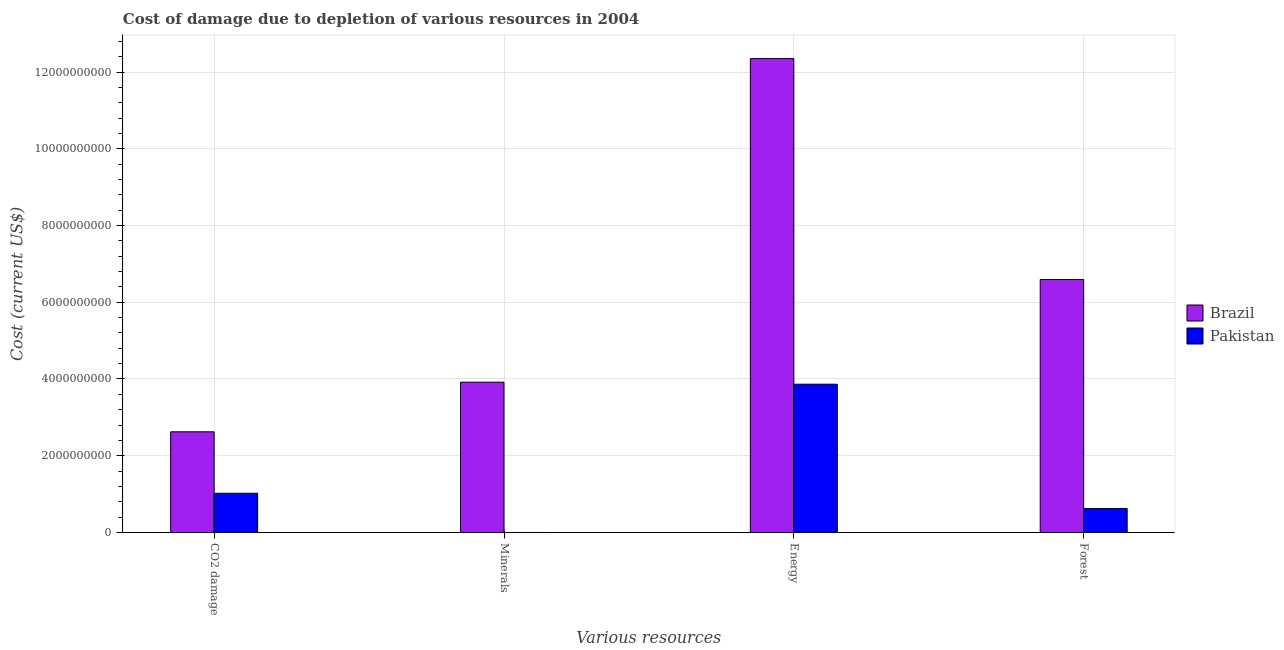How many different coloured bars are there?
Ensure brevity in your answer.  2. Are the number of bars per tick equal to the number of legend labels?
Ensure brevity in your answer.  Yes. Are the number of bars on each tick of the X-axis equal?
Offer a terse response. Yes. How many bars are there on the 1st tick from the left?
Provide a short and direct response. 2. How many bars are there on the 1st tick from the right?
Your answer should be very brief. 2. What is the label of the 2nd group of bars from the left?
Keep it short and to the point. Minerals. What is the cost of damage due to depletion of energy in Brazil?
Your answer should be very brief. 1.24e+1. Across all countries, what is the maximum cost of damage due to depletion of coal?
Your response must be concise. 2.62e+09. Across all countries, what is the minimum cost of damage due to depletion of coal?
Your answer should be compact. 1.02e+09. In which country was the cost of damage due to depletion of coal minimum?
Your answer should be compact. Pakistan. What is the total cost of damage due to depletion of forests in the graph?
Your answer should be very brief. 7.22e+09. What is the difference between the cost of damage due to depletion of coal in Pakistan and that in Brazil?
Provide a short and direct response. -1.60e+09. What is the difference between the cost of damage due to depletion of forests in Pakistan and the cost of damage due to depletion of energy in Brazil?
Make the answer very short. -1.17e+1. What is the average cost of damage due to depletion of coal per country?
Offer a very short reply. 1.82e+09. What is the difference between the cost of damage due to depletion of forests and cost of damage due to depletion of coal in Pakistan?
Offer a very short reply. -3.98e+08. What is the ratio of the cost of damage due to depletion of energy in Pakistan to that in Brazil?
Give a very brief answer. 0.31. Is the cost of damage due to depletion of coal in Pakistan less than that in Brazil?
Keep it short and to the point. Yes. Is the difference between the cost of damage due to depletion of energy in Pakistan and Brazil greater than the difference between the cost of damage due to depletion of coal in Pakistan and Brazil?
Your answer should be compact. No. What is the difference between the highest and the second highest cost of damage due to depletion of energy?
Make the answer very short. 8.49e+09. What is the difference between the highest and the lowest cost of damage due to depletion of forests?
Provide a succinct answer. 5.97e+09. Is the sum of the cost of damage due to depletion of energy in Brazil and Pakistan greater than the maximum cost of damage due to depletion of coal across all countries?
Give a very brief answer. Yes. What does the 2nd bar from the right in Minerals represents?
Your answer should be compact. Brazil. How many bars are there?
Make the answer very short. 8. Are all the bars in the graph horizontal?
Your answer should be very brief. No. How many countries are there in the graph?
Provide a short and direct response. 2. Does the graph contain any zero values?
Give a very brief answer. No. Does the graph contain grids?
Your answer should be very brief. Yes. What is the title of the graph?
Your answer should be compact. Cost of damage due to depletion of various resources in 2004 . What is the label or title of the X-axis?
Give a very brief answer. Various resources. What is the label or title of the Y-axis?
Provide a short and direct response. Cost (current US$). What is the Cost (current US$) of Brazil in CO2 damage?
Offer a terse response. 2.62e+09. What is the Cost (current US$) of Pakistan in CO2 damage?
Your response must be concise. 1.02e+09. What is the Cost (current US$) of Brazil in Minerals?
Keep it short and to the point. 3.92e+09. What is the Cost (current US$) in Pakistan in Minerals?
Ensure brevity in your answer.  2.90e+04. What is the Cost (current US$) of Brazil in Energy?
Make the answer very short. 1.24e+1. What is the Cost (current US$) of Pakistan in Energy?
Your answer should be compact. 3.86e+09. What is the Cost (current US$) of Brazil in Forest?
Offer a very short reply. 6.59e+09. What is the Cost (current US$) of Pakistan in Forest?
Ensure brevity in your answer.  6.24e+08. Across all Various resources, what is the maximum Cost (current US$) of Brazil?
Ensure brevity in your answer.  1.24e+1. Across all Various resources, what is the maximum Cost (current US$) of Pakistan?
Offer a very short reply. 3.86e+09. Across all Various resources, what is the minimum Cost (current US$) in Brazil?
Your answer should be compact. 2.62e+09. Across all Various resources, what is the minimum Cost (current US$) in Pakistan?
Offer a very short reply. 2.90e+04. What is the total Cost (current US$) of Brazil in the graph?
Your answer should be compact. 2.55e+1. What is the total Cost (current US$) of Pakistan in the graph?
Keep it short and to the point. 5.51e+09. What is the difference between the Cost (current US$) in Brazil in CO2 damage and that in Minerals?
Keep it short and to the point. -1.29e+09. What is the difference between the Cost (current US$) in Pakistan in CO2 damage and that in Minerals?
Your response must be concise. 1.02e+09. What is the difference between the Cost (current US$) in Brazil in CO2 damage and that in Energy?
Offer a terse response. -9.73e+09. What is the difference between the Cost (current US$) in Pakistan in CO2 damage and that in Energy?
Make the answer very short. -2.84e+09. What is the difference between the Cost (current US$) of Brazil in CO2 damage and that in Forest?
Your answer should be very brief. -3.97e+09. What is the difference between the Cost (current US$) of Pakistan in CO2 damage and that in Forest?
Your answer should be compact. 3.98e+08. What is the difference between the Cost (current US$) of Brazil in Minerals and that in Energy?
Offer a terse response. -8.43e+09. What is the difference between the Cost (current US$) in Pakistan in Minerals and that in Energy?
Make the answer very short. -3.86e+09. What is the difference between the Cost (current US$) in Brazil in Minerals and that in Forest?
Make the answer very short. -2.68e+09. What is the difference between the Cost (current US$) of Pakistan in Minerals and that in Forest?
Make the answer very short. -6.24e+08. What is the difference between the Cost (current US$) of Brazil in Energy and that in Forest?
Make the answer very short. 5.76e+09. What is the difference between the Cost (current US$) in Pakistan in Energy and that in Forest?
Make the answer very short. 3.24e+09. What is the difference between the Cost (current US$) in Brazil in CO2 damage and the Cost (current US$) in Pakistan in Minerals?
Provide a succinct answer. 2.62e+09. What is the difference between the Cost (current US$) in Brazil in CO2 damage and the Cost (current US$) in Pakistan in Energy?
Offer a terse response. -1.24e+09. What is the difference between the Cost (current US$) in Brazil in CO2 damage and the Cost (current US$) in Pakistan in Forest?
Keep it short and to the point. 2.00e+09. What is the difference between the Cost (current US$) of Brazil in Minerals and the Cost (current US$) of Pakistan in Energy?
Make the answer very short. 5.27e+07. What is the difference between the Cost (current US$) of Brazil in Minerals and the Cost (current US$) of Pakistan in Forest?
Make the answer very short. 3.29e+09. What is the difference between the Cost (current US$) of Brazil in Energy and the Cost (current US$) of Pakistan in Forest?
Make the answer very short. 1.17e+1. What is the average Cost (current US$) of Brazil per Various resources?
Your answer should be very brief. 6.37e+09. What is the average Cost (current US$) of Pakistan per Various resources?
Your answer should be compact. 1.38e+09. What is the difference between the Cost (current US$) in Brazil and Cost (current US$) in Pakistan in CO2 damage?
Provide a short and direct response. 1.60e+09. What is the difference between the Cost (current US$) in Brazil and Cost (current US$) in Pakistan in Minerals?
Your response must be concise. 3.92e+09. What is the difference between the Cost (current US$) of Brazil and Cost (current US$) of Pakistan in Energy?
Provide a short and direct response. 8.49e+09. What is the difference between the Cost (current US$) in Brazil and Cost (current US$) in Pakistan in Forest?
Provide a succinct answer. 5.97e+09. What is the ratio of the Cost (current US$) in Brazil in CO2 damage to that in Minerals?
Your answer should be compact. 0.67. What is the ratio of the Cost (current US$) in Pakistan in CO2 damage to that in Minerals?
Ensure brevity in your answer.  3.53e+04. What is the ratio of the Cost (current US$) in Brazil in CO2 damage to that in Energy?
Offer a very short reply. 0.21. What is the ratio of the Cost (current US$) in Pakistan in CO2 damage to that in Energy?
Keep it short and to the point. 0.26. What is the ratio of the Cost (current US$) in Brazil in CO2 damage to that in Forest?
Your response must be concise. 0.4. What is the ratio of the Cost (current US$) of Pakistan in CO2 damage to that in Forest?
Offer a terse response. 1.64. What is the ratio of the Cost (current US$) in Brazil in Minerals to that in Energy?
Give a very brief answer. 0.32. What is the ratio of the Cost (current US$) of Pakistan in Minerals to that in Energy?
Offer a terse response. 0. What is the ratio of the Cost (current US$) in Brazil in Minerals to that in Forest?
Give a very brief answer. 0.59. What is the ratio of the Cost (current US$) in Pakistan in Minerals to that in Forest?
Make the answer very short. 0. What is the ratio of the Cost (current US$) in Brazil in Energy to that in Forest?
Your response must be concise. 1.87. What is the ratio of the Cost (current US$) in Pakistan in Energy to that in Forest?
Offer a very short reply. 6.19. What is the difference between the highest and the second highest Cost (current US$) in Brazil?
Make the answer very short. 5.76e+09. What is the difference between the highest and the second highest Cost (current US$) of Pakistan?
Give a very brief answer. 2.84e+09. What is the difference between the highest and the lowest Cost (current US$) of Brazil?
Your response must be concise. 9.73e+09. What is the difference between the highest and the lowest Cost (current US$) in Pakistan?
Provide a succinct answer. 3.86e+09. 